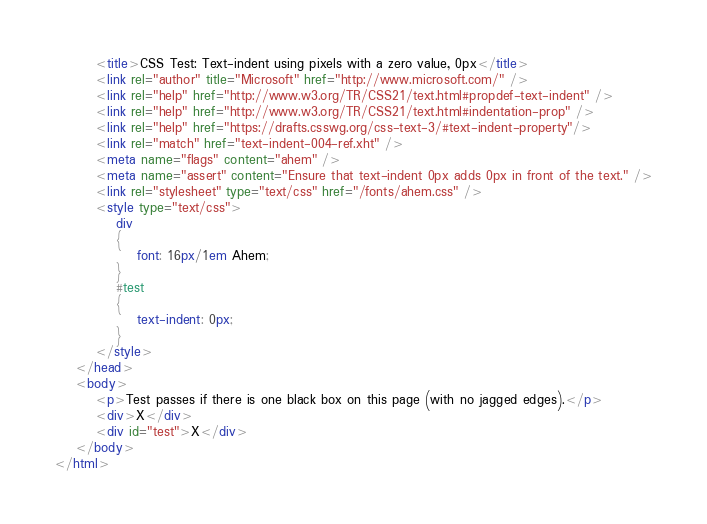<code> <loc_0><loc_0><loc_500><loc_500><_HTML_>        <title>CSS Test: Text-indent using pixels with a zero value, 0px</title>
        <link rel="author" title="Microsoft" href="http://www.microsoft.com/" />
        <link rel="help" href="http://www.w3.org/TR/CSS21/text.html#propdef-text-indent" />
        <link rel="help" href="http://www.w3.org/TR/CSS21/text.html#indentation-prop" />
        <link rel="help" href="https://drafts.csswg.org/css-text-3/#text-indent-property"/>
        <link rel="match" href="text-indent-004-ref.xht" />
        <meta name="flags" content="ahem" />
        <meta name="assert" content="Ensure that text-indent 0px adds 0px in front of the text." />
        <link rel="stylesheet" type="text/css" href="/fonts/ahem.css" />
        <style type="text/css">
            div
            {
                font: 16px/1em Ahem;
            }
            #test
            {
                text-indent: 0px;
            }
        </style>
    </head>
    <body>
        <p>Test passes if there is one black box on this page (with no jagged edges).</p>
        <div>X</div>
        <div id="test">X</div>
    </body>
</html>
</code> 